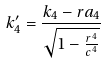Convert formula to latex. <formula><loc_0><loc_0><loc_500><loc_500>k _ { 4 } ^ { \prime } = \frac { k _ { 4 } - r a _ { 4 } } { \sqrt { 1 - \frac { r ^ { 4 } } { c ^ { 4 } } } }</formula> 